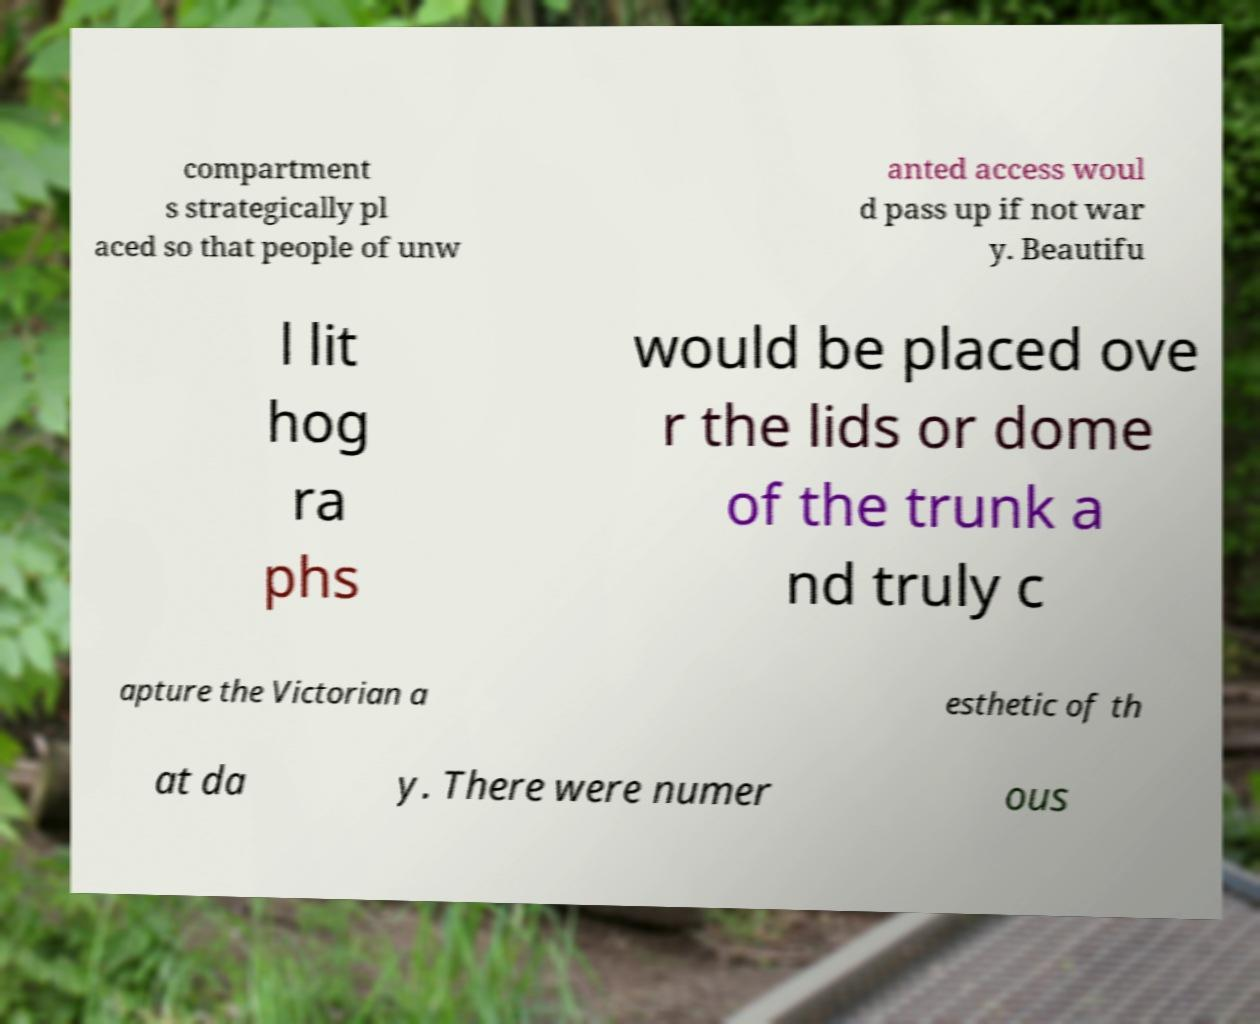For documentation purposes, I need the text within this image transcribed. Could you provide that? compartment s strategically pl aced so that people of unw anted access woul d pass up if not war y. Beautifu l lit hog ra phs would be placed ove r the lids or dome of the trunk a nd truly c apture the Victorian a esthetic of th at da y. There were numer ous 